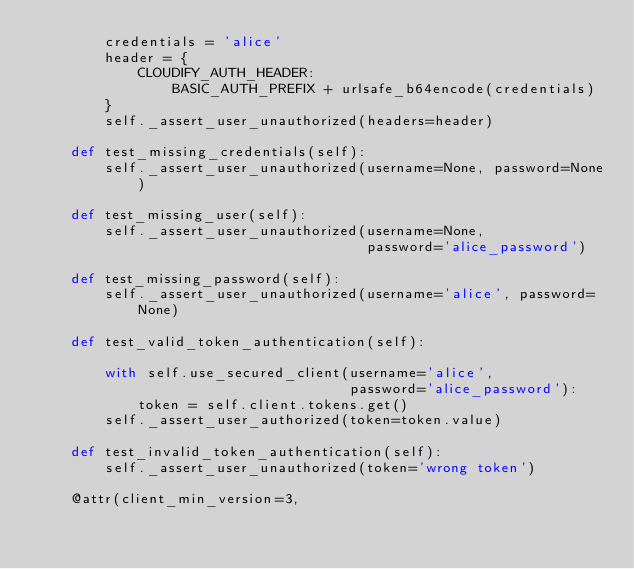<code> <loc_0><loc_0><loc_500><loc_500><_Python_>        credentials = 'alice'
        header = {
            CLOUDIFY_AUTH_HEADER:
                BASIC_AUTH_PREFIX + urlsafe_b64encode(credentials)
        }
        self._assert_user_unauthorized(headers=header)

    def test_missing_credentials(self):
        self._assert_user_unauthorized(username=None, password=None)

    def test_missing_user(self):
        self._assert_user_unauthorized(username=None,
                                       password='alice_password')

    def test_missing_password(self):
        self._assert_user_unauthorized(username='alice', password=None)

    def test_valid_token_authentication(self):

        with self.use_secured_client(username='alice',
                                     password='alice_password'):
            token = self.client.tokens.get()
        self._assert_user_authorized(token=token.value)

    def test_invalid_token_authentication(self):
        self._assert_user_unauthorized(token='wrong token')

    @attr(client_min_version=3,</code> 